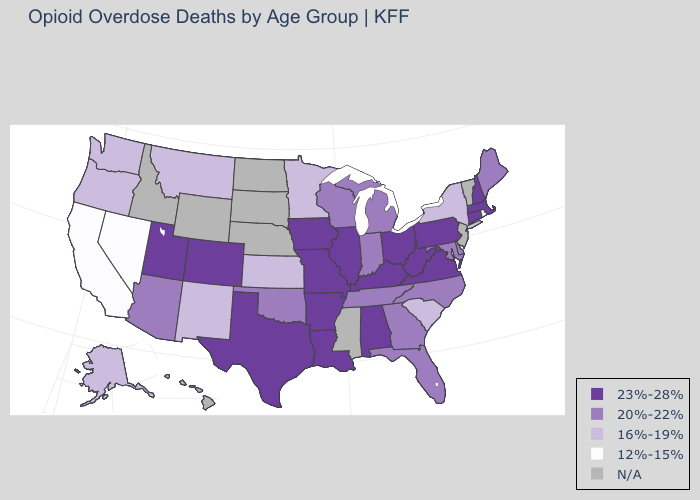What is the value of Pennsylvania?
Write a very short answer. 23%-28%. Which states have the highest value in the USA?
Keep it brief. Alabama, Arkansas, Colorado, Connecticut, Illinois, Iowa, Kentucky, Louisiana, Massachusetts, Missouri, New Hampshire, Ohio, Pennsylvania, Texas, Utah, Virginia, West Virginia. What is the value of Maryland?
Short answer required. 20%-22%. Among the states that border Wisconsin , does Iowa have the lowest value?
Concise answer only. No. Name the states that have a value in the range 16%-19%?
Concise answer only. Alaska, Kansas, Minnesota, Montana, New Mexico, New York, Oregon, South Carolina, Washington. Among the states that border Colorado , which have the lowest value?
Give a very brief answer. Kansas, New Mexico. Does the map have missing data?
Write a very short answer. Yes. Which states have the lowest value in the Northeast?
Write a very short answer. Rhode Island. What is the value of Ohio?
Keep it brief. 23%-28%. Which states have the highest value in the USA?
Keep it brief. Alabama, Arkansas, Colorado, Connecticut, Illinois, Iowa, Kentucky, Louisiana, Massachusetts, Missouri, New Hampshire, Ohio, Pennsylvania, Texas, Utah, Virginia, West Virginia. Does Missouri have the highest value in the USA?
Write a very short answer. Yes. Does Missouri have the lowest value in the USA?
Keep it brief. No. Does Louisiana have the highest value in the South?
Concise answer only. Yes. What is the highest value in the MidWest ?
Give a very brief answer. 23%-28%. Name the states that have a value in the range N/A?
Answer briefly. Hawaii, Idaho, Mississippi, Nebraska, New Jersey, North Dakota, South Dakota, Vermont, Wyoming. 